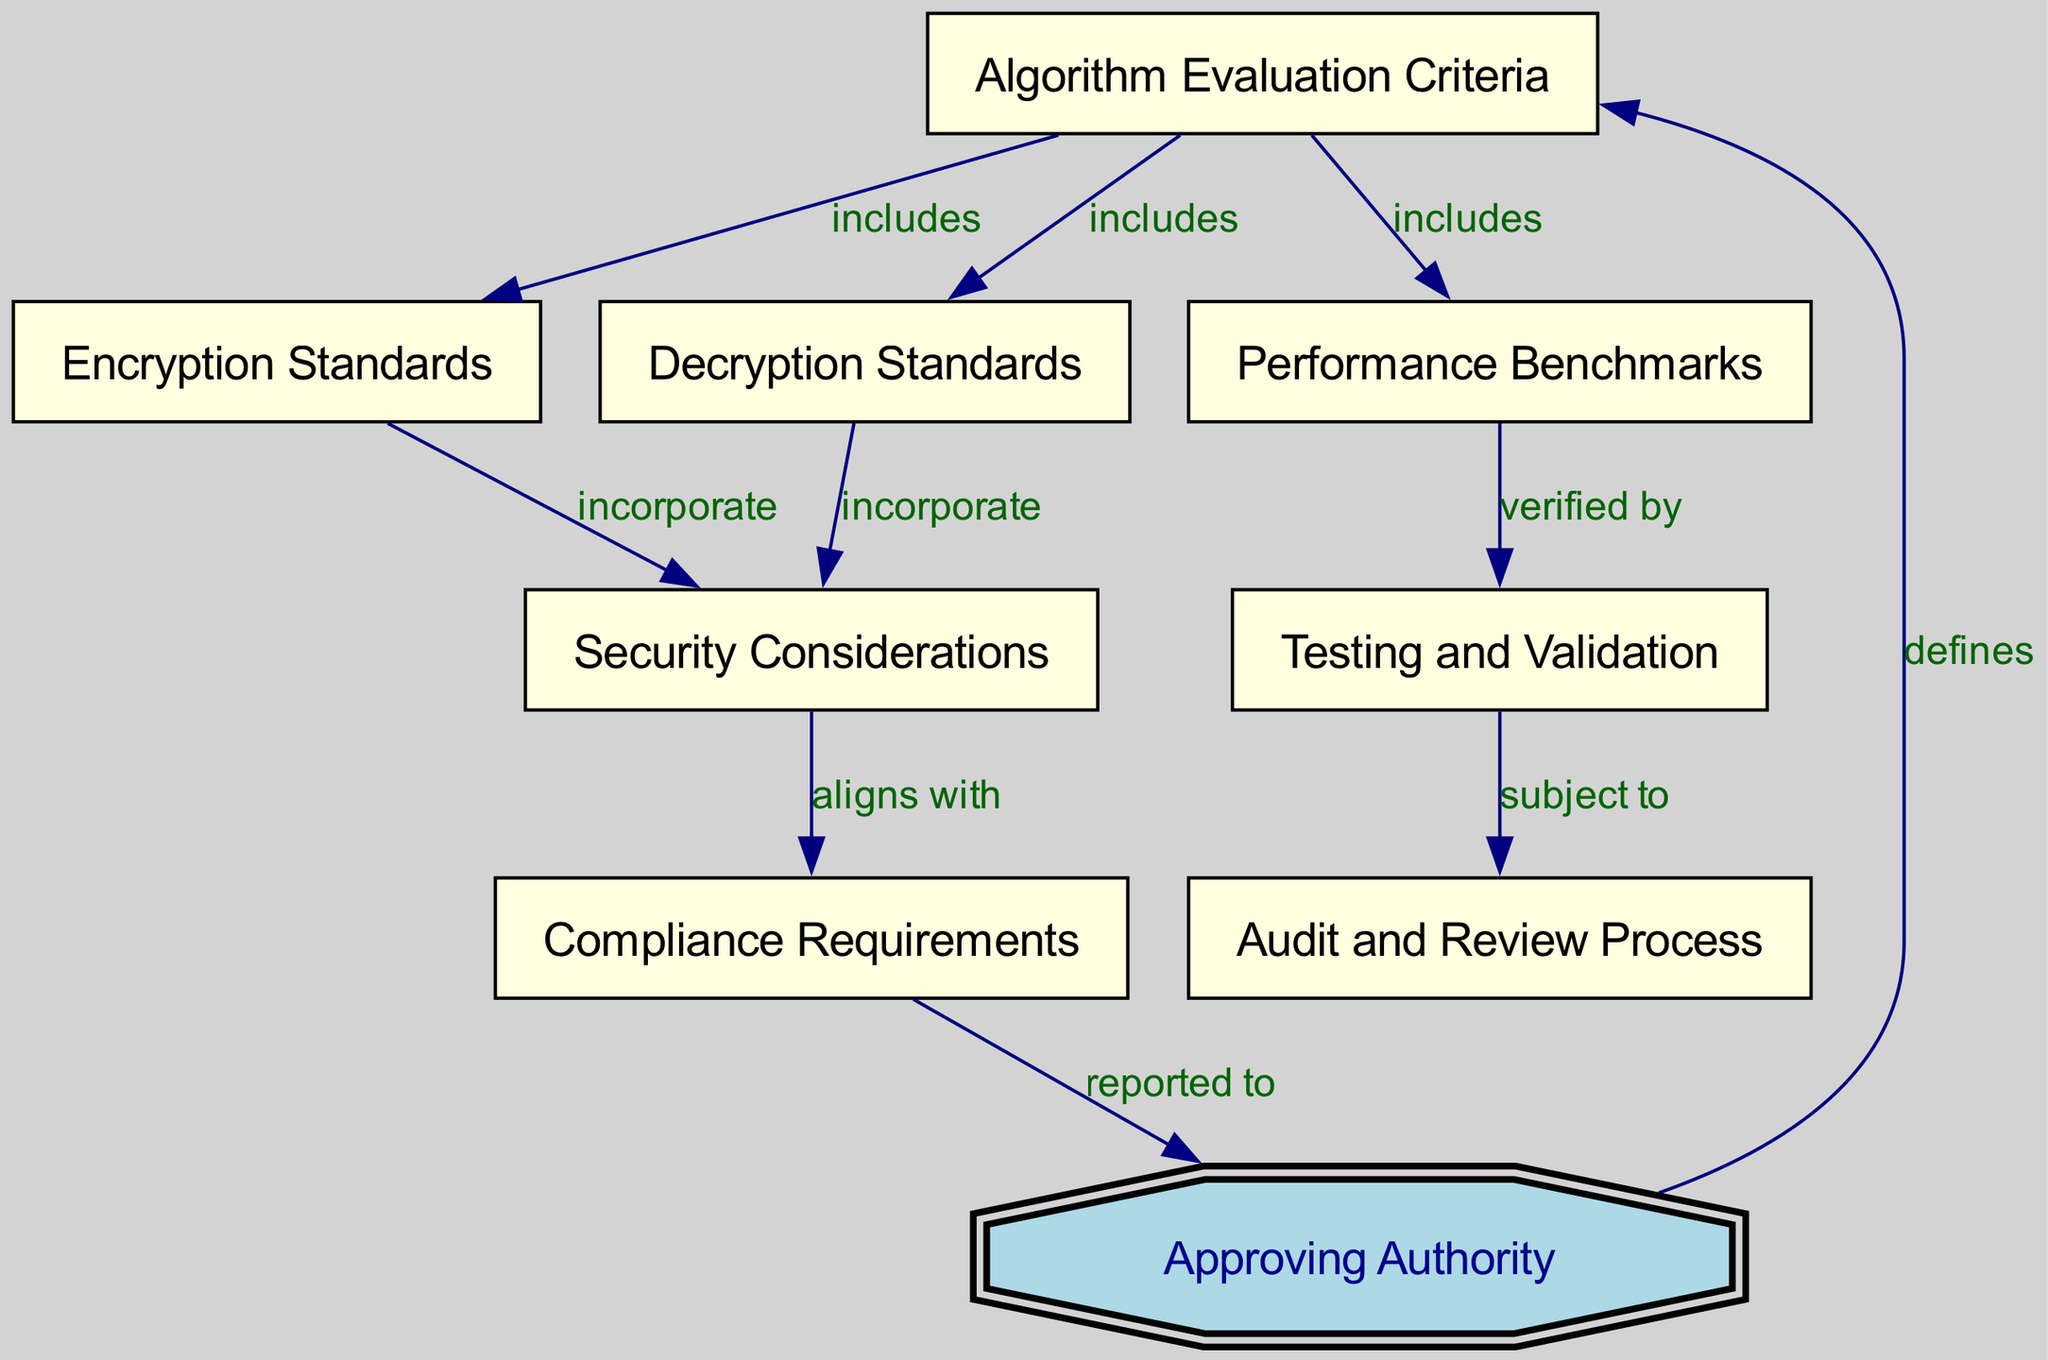What defines the algorithm evaluation criteria? The "Approving Authority" node is directly connected to the "Algorithm Evaluation Criteria" node, indicating that the authority defines the criteria used for evaluating algorithms.
Answer: Approving Authority How many standards are included in the algorithm evaluation criteria? The "Algorithm Evaluation Criteria" node has direct connections to two nodes: "Encryption Standards" and "Decryption Standards." Thus, it includes two standards.
Answer: Two What do encryption standards incorporate? The "Encryption Standards" node is connected to the "Security Considerations" node, signifying that these standards incorporate security measures to enhance encryption protocols.
Answer: Security Considerations Which process is subject to testing and validation? The "Testing and Validation" node is connected to the "Audit and Review Process," meaning that the processes involved in testing algorithms are subject to audits and reviews for compliance and effectiveness.
Answer: Audit and Review Process To whom is compliance requirements reported? The "Compliance Requirements" node is connected to the "Approving Authority" node, indicating that these requirements are reported to the authority overseeing algorithm approvals.
Answer: Approving Authority What performance benchmarks are verified by testing and validation? The "Performance Benchmarks" node is linked to "Testing and Validation," showing that performance metrics are verified through specific tests and validations of the algorithms being evaluated.
Answer: Testing and Validation What aligns with security considerations? "Compliance Requirements" is connected to "Security Considerations," indicating that compliance measures taken must align with the security standards set forth in the encryption and decryption processes.
Answer: Compliance Requirements How many total nodes are present in the diagram? The diagram lists eight distinct concepts, making up the total number of nodes represented in the concept map.
Answer: Eight What are the two types of standards included in the algorithm evaluation criteria? The node "Algorithm Evaluation Criteria" links to "Encryption Standards" and "Decryption Standards," meaning these are the two types of standards included in the criteria for evaluation.
Answer: Encryption Standards and Decryption Standards 